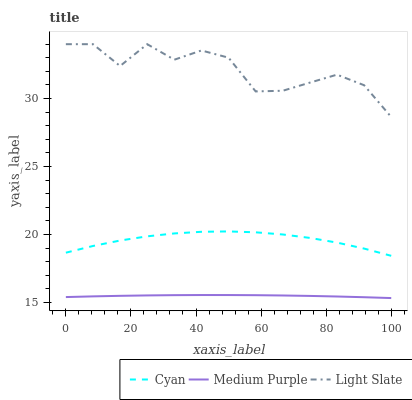Does Medium Purple have the minimum area under the curve?
Answer yes or no. Yes. Does Light Slate have the maximum area under the curve?
Answer yes or no. Yes. Does Cyan have the minimum area under the curve?
Answer yes or no. No. Does Cyan have the maximum area under the curve?
Answer yes or no. No. Is Medium Purple the smoothest?
Answer yes or no. Yes. Is Light Slate the roughest?
Answer yes or no. Yes. Is Cyan the smoothest?
Answer yes or no. No. Is Cyan the roughest?
Answer yes or no. No. Does Medium Purple have the lowest value?
Answer yes or no. Yes. Does Cyan have the lowest value?
Answer yes or no. No. Does Light Slate have the highest value?
Answer yes or no. Yes. Does Cyan have the highest value?
Answer yes or no. No. Is Cyan less than Light Slate?
Answer yes or no. Yes. Is Light Slate greater than Cyan?
Answer yes or no. Yes. Does Cyan intersect Light Slate?
Answer yes or no. No. 